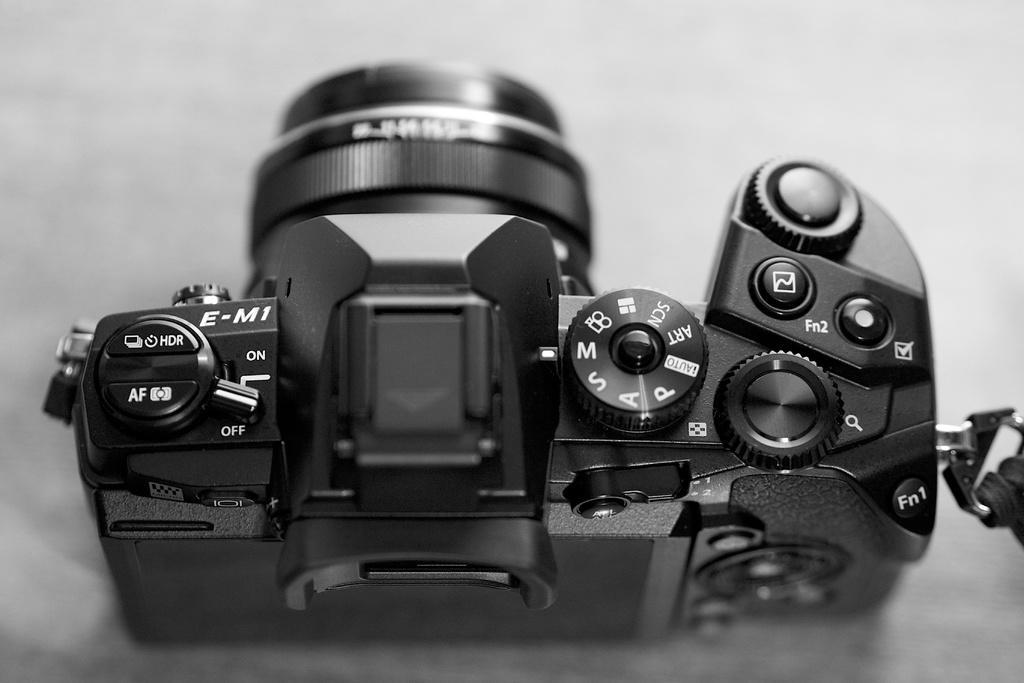How would you summarize this image in a sentence or two? In this image we can see the camera on the table. 